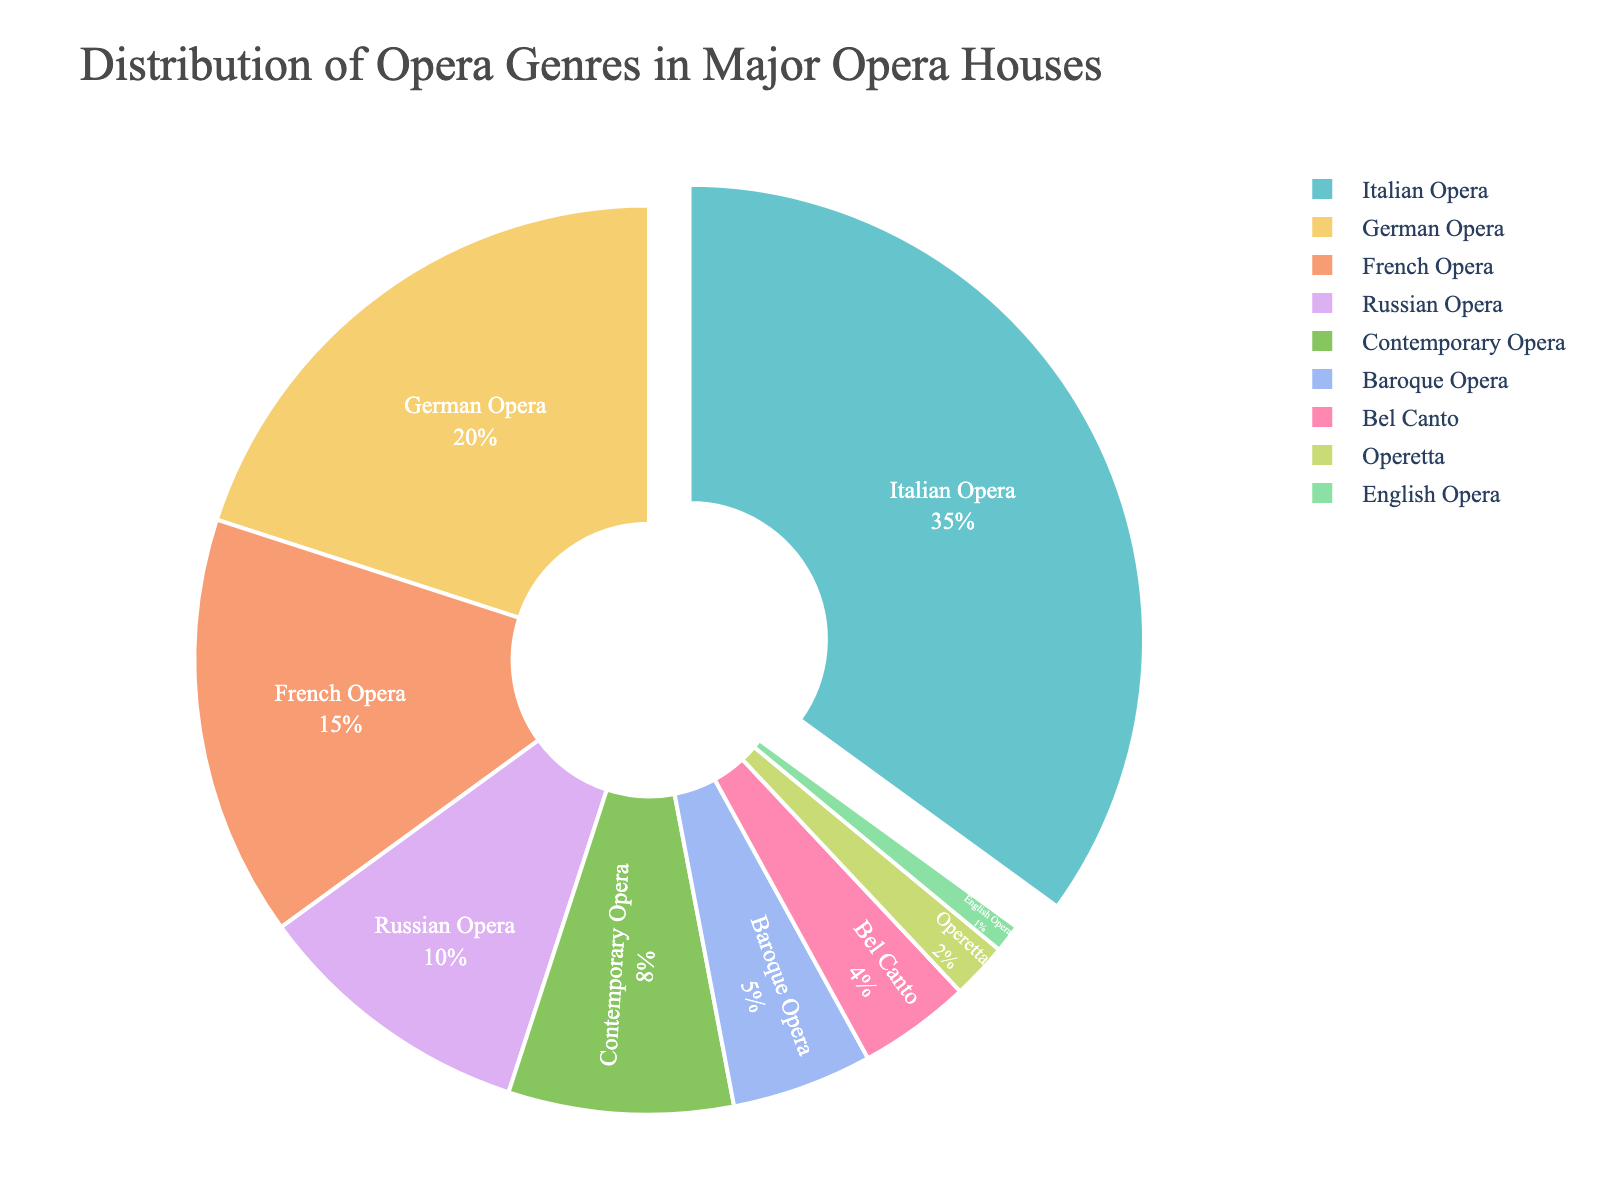What's the most performed opera genre at major opera houses? The figure highlights Italian Opera by pulling its segment out slightly from the rest, showing it has the largest percentage.
Answer: Italian Opera What is the combined percentage of German Opera and French Opera? Add the percentages of German Opera (20%) and French Opera (15%) together.
Answer: 35% Which genre has the smallest representation in the pie chart? The segment labeled English Opera accounts for only 1%.
Answer: English Opera By how many percentage points does Italian Opera exceed Russian Opera? Subtract the percentage of Russian Opera (10%) from the percentage of Italian Opera (35%).
Answer: 25 percentage points Between Bel Canto and Baroque Opera, which has a larger slice of the pie, and by how much? Bel Canto is 4% and Baroque Opera is 5%. Subtract Bel Canto's percentage from Baroque Opera's percentage.
Answer: Baroque Opera by 1% How much more popular are Contemporary Operas compared to Operettas? Contemporary Opera accounts for 8%, while Operetta accounts for 2%. Subtract the percentage of Operetta from Contemporary Opera.
Answer: 6 percentage points What is the total percentage of the genres that have a percentage less than 10% each? Sum the percentages of Contemporary Opera (8%), Baroque Opera (5%), Bel Canto (4%), Operetta (2%), and English Opera (1%).
Answer: 20% Which genre has exactly double the percentage compared to French Opera? Check which genre has a percentage that is double of French Opera's 15%. Since 15% x 2 = 30%, and no genre matches exactly, there is no exact double.
Answer: None What is the second least performed genre at major opera houses? The second smallest segment after English Opera (1%) is Operetta (2%).
Answer: Operetta How many more percentage points do Italian Operas account for compared to Contemporary Operas and German Operas combined? Combine the percentages of German Opera (20%) and Contemporary Opera (8%) to get 28%, then subtract from Italian Opera's percentage (35%).
Answer: 7 percentage points 